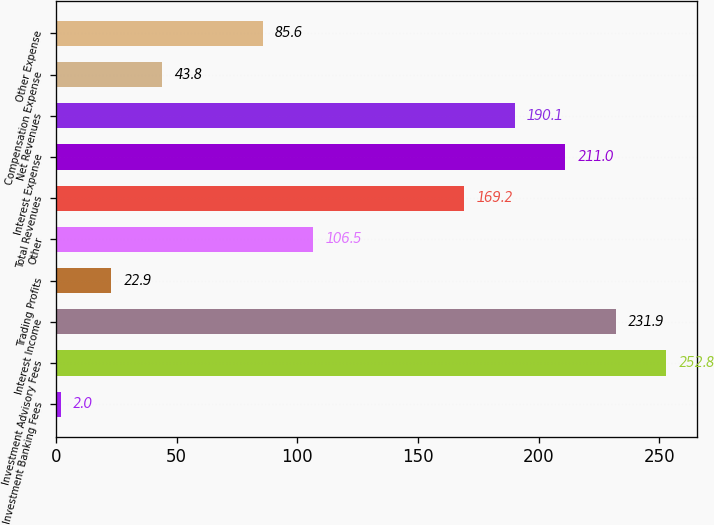Convert chart to OTSL. <chart><loc_0><loc_0><loc_500><loc_500><bar_chart><fcel>Investment Banking Fees<fcel>Investment Advisory Fees<fcel>Interest Income<fcel>Trading Profits<fcel>Other<fcel>Total Revenues<fcel>Interest Expense<fcel>Net Revenues<fcel>Compensation Expense<fcel>Other Expense<nl><fcel>2<fcel>252.8<fcel>231.9<fcel>22.9<fcel>106.5<fcel>169.2<fcel>211<fcel>190.1<fcel>43.8<fcel>85.6<nl></chart> 